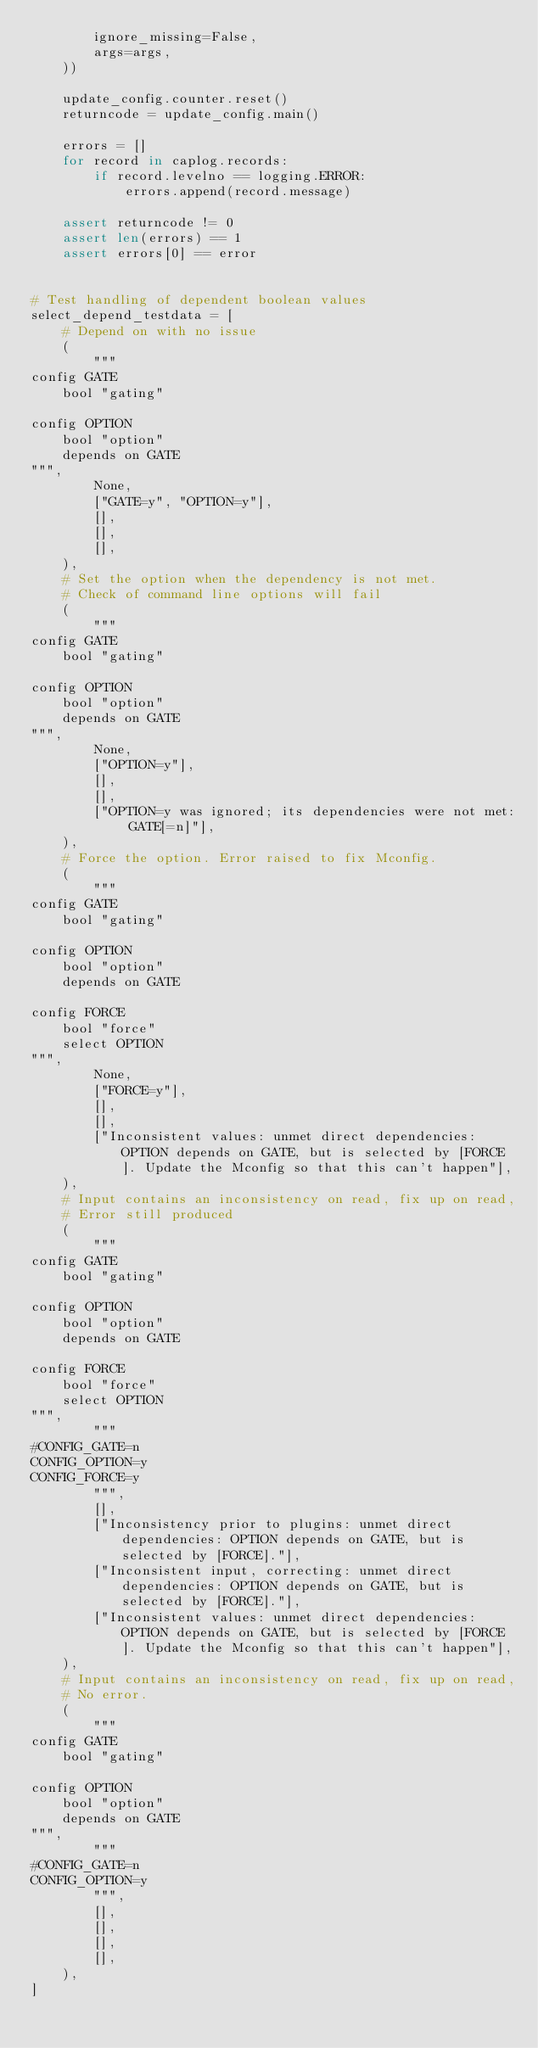Convert code to text. <code><loc_0><loc_0><loc_500><loc_500><_Python_>        ignore_missing=False,
        args=args,
    ))

    update_config.counter.reset()
    returncode = update_config.main()

    errors = []
    for record in caplog.records:
        if record.levelno == logging.ERROR:
            errors.append(record.message)

    assert returncode != 0
    assert len(errors) == 1
    assert errors[0] == error


# Test handling of dependent boolean values
select_depend_testdata = [
    # Depend on with no issue
    (
        """
config GATE
    bool "gating"

config OPTION
    bool "option"
    depends on GATE
""",
        None,
        ["GATE=y", "OPTION=y"],
        [],
        [],
        [],
    ),
    # Set the option when the dependency is not met.
    # Check of command line options will fail
    (
        """
config GATE
    bool "gating"

config OPTION
    bool "option"
    depends on GATE
""",
        None,
        ["OPTION=y"],
        [],
        [],
        ["OPTION=y was ignored; its dependencies were not met: GATE[=n]"],
    ),
    # Force the option. Error raised to fix Mconfig.
    (
        """
config GATE
    bool "gating"

config OPTION
    bool "option"
    depends on GATE

config FORCE
    bool "force"
    select OPTION
""",
        None,
        ["FORCE=y"],
        [],
        [],
        ["Inconsistent values: unmet direct dependencies: OPTION depends on GATE, but is selected by [FORCE]. Update the Mconfig so that this can't happen"],
    ),
    # Input contains an inconsistency on read, fix up on read,
    # Error still produced
    (
        """
config GATE
    bool "gating"

config OPTION
    bool "option"
    depends on GATE

config FORCE
    bool "force"
    select OPTION
""",
        """
#CONFIG_GATE=n
CONFIG_OPTION=y
CONFIG_FORCE=y
        """,
        [],
        ["Inconsistency prior to plugins: unmet direct dependencies: OPTION depends on GATE, but is selected by [FORCE]."],
        ["Inconsistent input, correcting: unmet direct dependencies: OPTION depends on GATE, but is selected by [FORCE]."],
        ["Inconsistent values: unmet direct dependencies: OPTION depends on GATE, but is selected by [FORCE]. Update the Mconfig so that this can't happen"],
    ),
    # Input contains an inconsistency on read, fix up on read,
    # No error.
    (
        """
config GATE
    bool "gating"

config OPTION
    bool "option"
    depends on GATE
""",
        """
#CONFIG_GATE=n
CONFIG_OPTION=y
        """,
        [],
        [],
        [],
        [],
    ),
]
</code> 